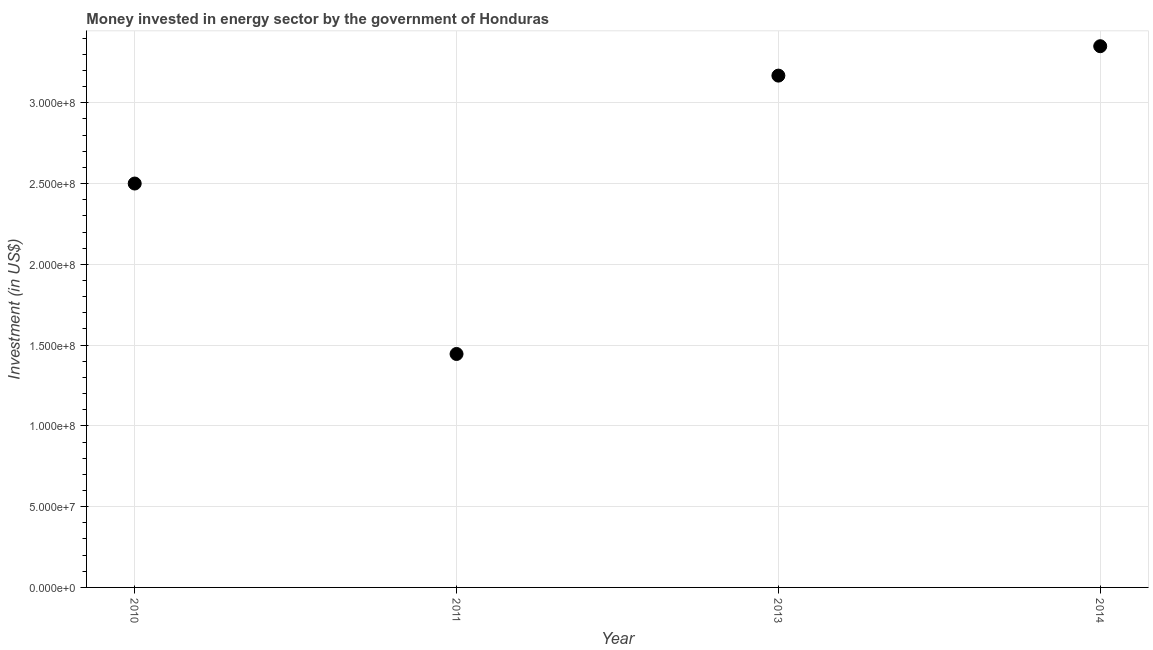What is the investment in energy in 2010?
Your response must be concise. 2.50e+08. Across all years, what is the maximum investment in energy?
Ensure brevity in your answer.  3.35e+08. Across all years, what is the minimum investment in energy?
Provide a succinct answer. 1.44e+08. In which year was the investment in energy maximum?
Your answer should be very brief. 2014. In which year was the investment in energy minimum?
Offer a terse response. 2011. What is the sum of the investment in energy?
Keep it short and to the point. 1.05e+09. What is the difference between the investment in energy in 2010 and 2011?
Provide a succinct answer. 1.06e+08. What is the average investment in energy per year?
Your answer should be compact. 2.62e+08. What is the median investment in energy?
Ensure brevity in your answer.  2.83e+08. Do a majority of the years between 2013 and 2011 (inclusive) have investment in energy greater than 90000000 US$?
Make the answer very short. No. What is the ratio of the investment in energy in 2011 to that in 2013?
Your response must be concise. 0.46. Is the difference between the investment in energy in 2010 and 2011 greater than the difference between any two years?
Offer a terse response. No. What is the difference between the highest and the second highest investment in energy?
Make the answer very short. 1.82e+07. Is the sum of the investment in energy in 2010 and 2013 greater than the maximum investment in energy across all years?
Offer a terse response. Yes. What is the difference between the highest and the lowest investment in energy?
Provide a short and direct response. 1.90e+08. How many dotlines are there?
Offer a terse response. 1. How many years are there in the graph?
Provide a succinct answer. 4. What is the difference between two consecutive major ticks on the Y-axis?
Your response must be concise. 5.00e+07. Does the graph contain any zero values?
Provide a short and direct response. No. What is the title of the graph?
Keep it short and to the point. Money invested in energy sector by the government of Honduras. What is the label or title of the X-axis?
Ensure brevity in your answer.  Year. What is the label or title of the Y-axis?
Your answer should be very brief. Investment (in US$). What is the Investment (in US$) in 2010?
Provide a short and direct response. 2.50e+08. What is the Investment (in US$) in 2011?
Give a very brief answer. 1.44e+08. What is the Investment (in US$) in 2013?
Offer a very short reply. 3.17e+08. What is the Investment (in US$) in 2014?
Make the answer very short. 3.35e+08. What is the difference between the Investment (in US$) in 2010 and 2011?
Provide a succinct answer. 1.06e+08. What is the difference between the Investment (in US$) in 2010 and 2013?
Give a very brief answer. -6.68e+07. What is the difference between the Investment (in US$) in 2010 and 2014?
Make the answer very short. -8.50e+07. What is the difference between the Investment (in US$) in 2011 and 2013?
Give a very brief answer. -1.72e+08. What is the difference between the Investment (in US$) in 2011 and 2014?
Provide a succinct answer. -1.90e+08. What is the difference between the Investment (in US$) in 2013 and 2014?
Offer a very short reply. -1.82e+07. What is the ratio of the Investment (in US$) in 2010 to that in 2011?
Your response must be concise. 1.73. What is the ratio of the Investment (in US$) in 2010 to that in 2013?
Offer a terse response. 0.79. What is the ratio of the Investment (in US$) in 2010 to that in 2014?
Your response must be concise. 0.75. What is the ratio of the Investment (in US$) in 2011 to that in 2013?
Your response must be concise. 0.46. What is the ratio of the Investment (in US$) in 2011 to that in 2014?
Offer a very short reply. 0.43. What is the ratio of the Investment (in US$) in 2013 to that in 2014?
Offer a terse response. 0.95. 